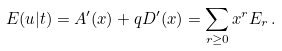Convert formula to latex. <formula><loc_0><loc_0><loc_500><loc_500>E ( u | t ) = A ^ { \prime } ( x ) + q D ^ { \prime } ( x ) = \sum _ { r \geq 0 } x ^ { r } E _ { r } \, .</formula> 